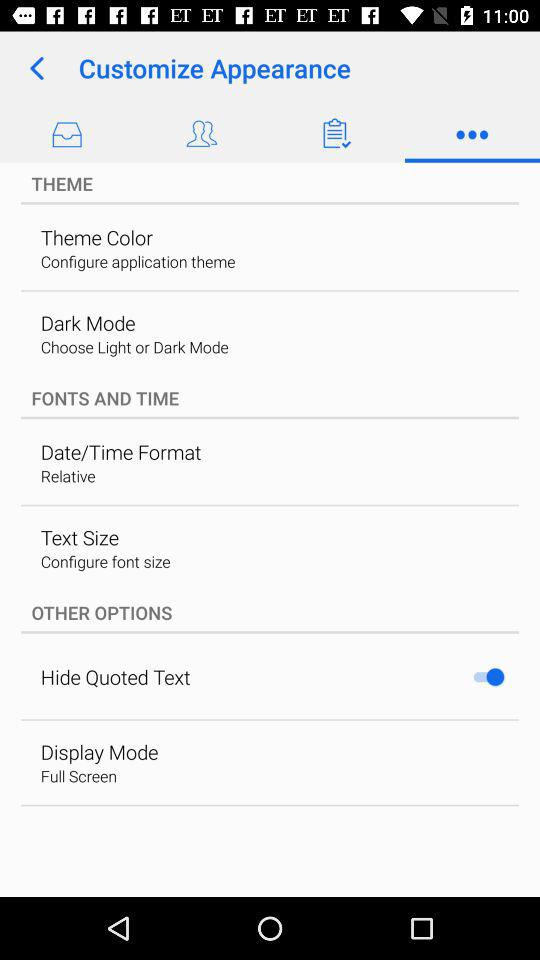Which date format is chosen? The chosen date format is "Relative". 